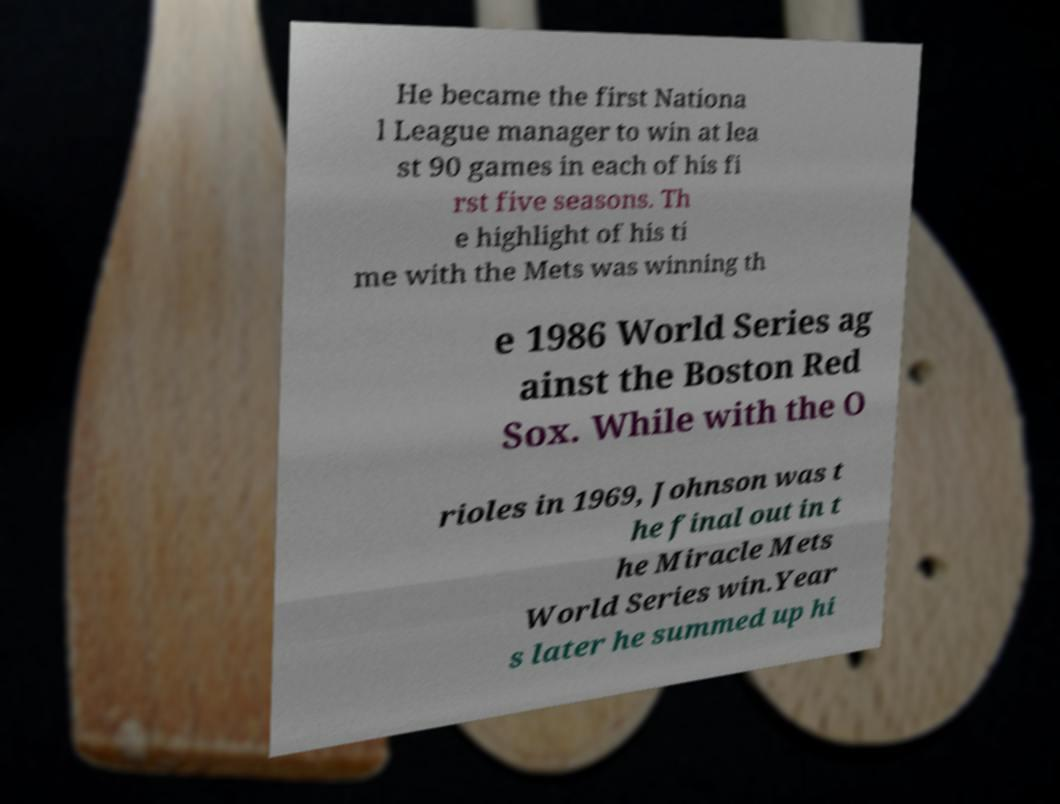Can you accurately transcribe the text from the provided image for me? He became the first Nationa l League manager to win at lea st 90 games in each of his fi rst five seasons. Th e highlight of his ti me with the Mets was winning th e 1986 World Series ag ainst the Boston Red Sox. While with the O rioles in 1969, Johnson was t he final out in t he Miracle Mets World Series win.Year s later he summed up hi 